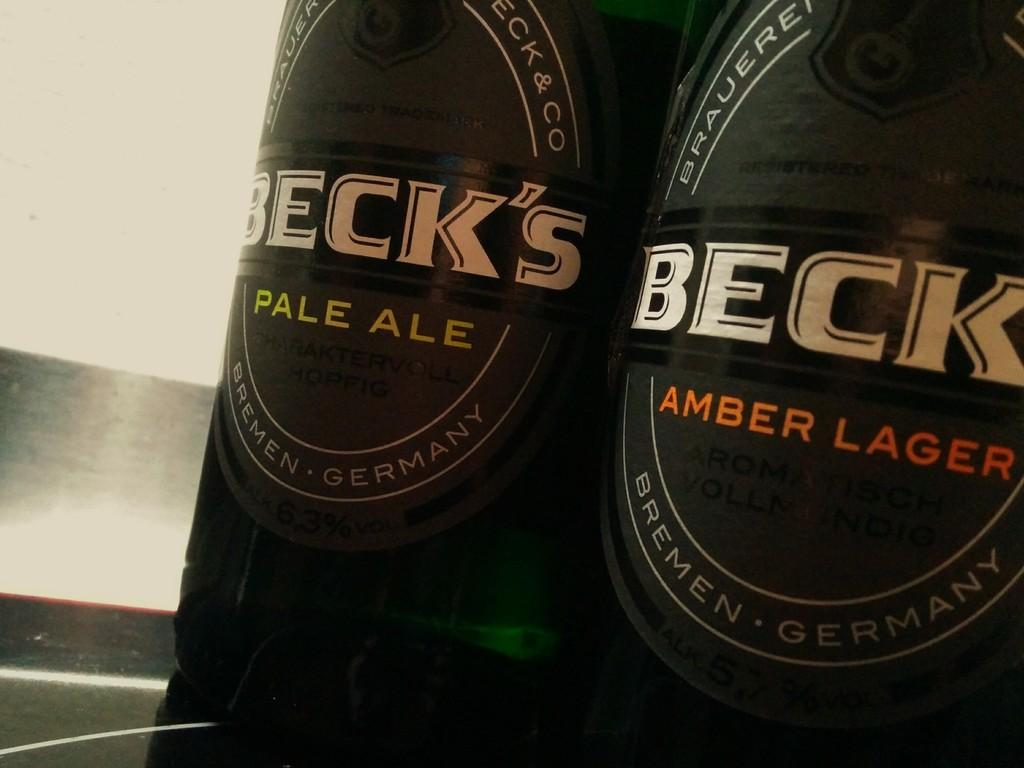Provide a one-sentence caption for the provided image. John enjoys two bottles Beck's in the favors of Pale Ale and Amber Lager. 